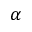<formula> <loc_0><loc_0><loc_500><loc_500>\alpha</formula> 